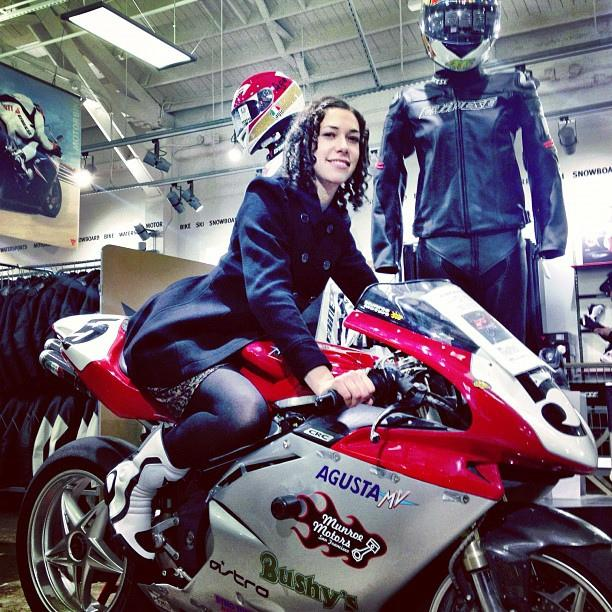What does the woman have on her feet? Please explain your reasoning. boots. The woman is wearing white boots. 